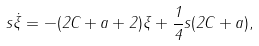Convert formula to latex. <formula><loc_0><loc_0><loc_500><loc_500>s \dot { \xi } = - ( 2 C + a + 2 ) \xi + \frac { 1 } { 4 } s ( 2 C + a ) ,</formula> 